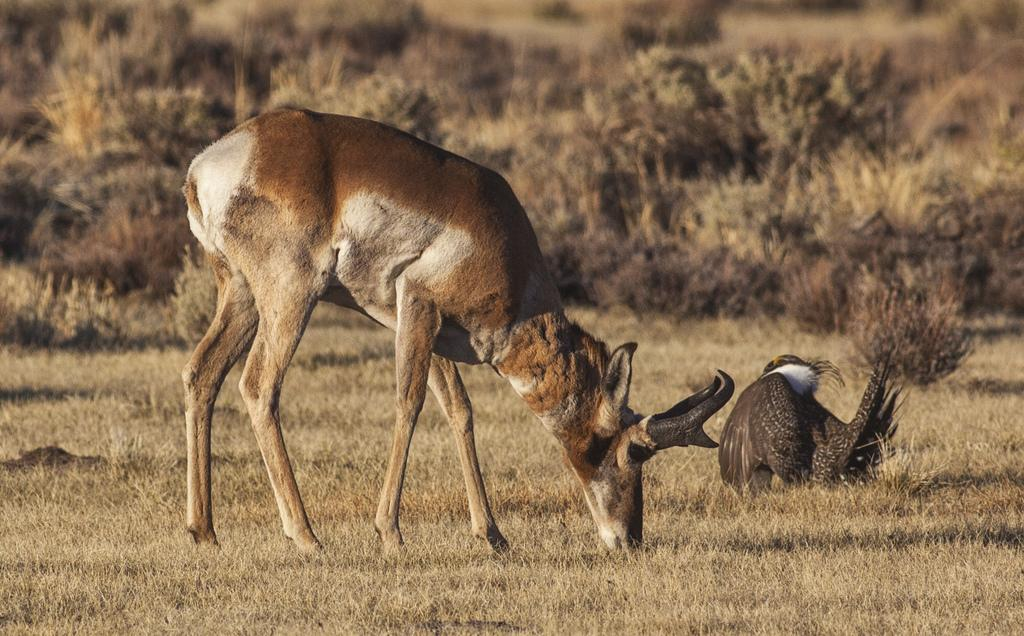What animals are in the center of the image? There is a bird and a deer in the center of the image. Can you describe the deer's appearance? The deer is brown and white in color. What type of vegetation can be seen in the background of the image? There are plants and grass in the background of the image. What else can be seen in the background of the image? There are a few other objects in the background of the image. What type of stick is the carpenter using to level the ground in the image? There is no carpenter or stick present in the image. The image features a bird and a deer in the center, with plants and grass in the background. 